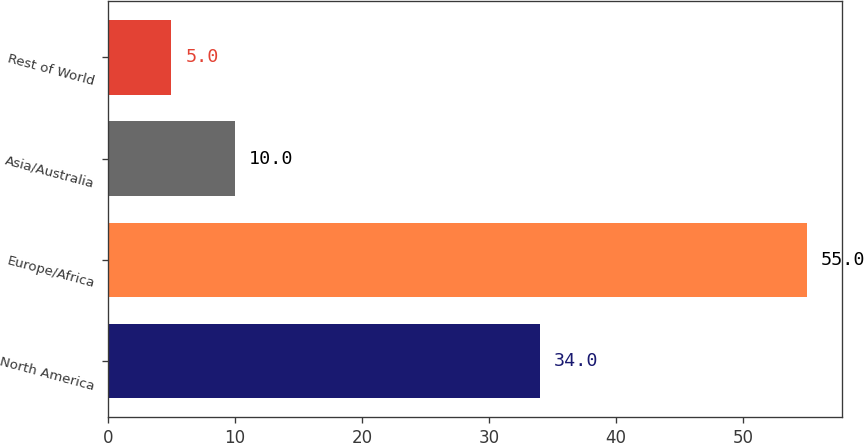Convert chart. <chart><loc_0><loc_0><loc_500><loc_500><bar_chart><fcel>North America<fcel>Europe/Africa<fcel>Asia/Australia<fcel>Rest of World<nl><fcel>34<fcel>55<fcel>10<fcel>5<nl></chart> 